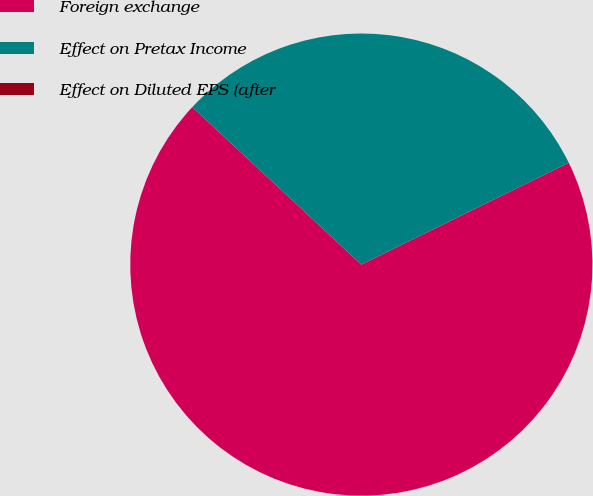Convert chart. <chart><loc_0><loc_0><loc_500><loc_500><pie_chart><fcel>Foreign exchange<fcel>Effect on Pretax Income<fcel>Effect on Diluted EPS (after<nl><fcel>69.2%<fcel>30.8%<fcel>0.0%<nl></chart> 